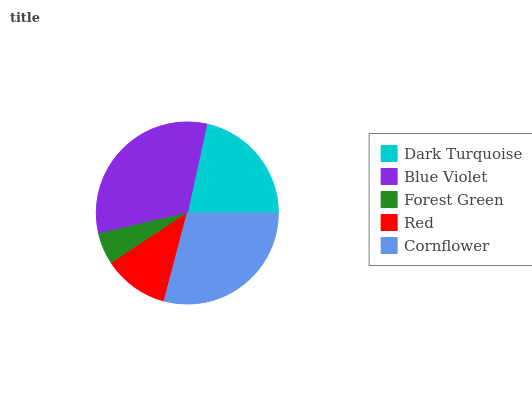Is Forest Green the minimum?
Answer yes or no. Yes. Is Blue Violet the maximum?
Answer yes or no. Yes. Is Blue Violet the minimum?
Answer yes or no. No. Is Forest Green the maximum?
Answer yes or no. No. Is Blue Violet greater than Forest Green?
Answer yes or no. Yes. Is Forest Green less than Blue Violet?
Answer yes or no. Yes. Is Forest Green greater than Blue Violet?
Answer yes or no. No. Is Blue Violet less than Forest Green?
Answer yes or no. No. Is Dark Turquoise the high median?
Answer yes or no. Yes. Is Dark Turquoise the low median?
Answer yes or no. Yes. Is Blue Violet the high median?
Answer yes or no. No. Is Blue Violet the low median?
Answer yes or no. No. 